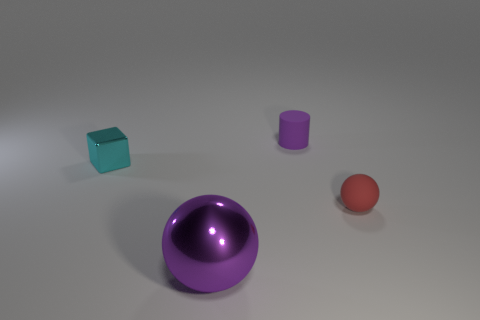Add 2 tiny matte things. How many objects exist? 6 Subtract all purple spheres. How many spheres are left? 1 Subtract 0 gray balls. How many objects are left? 4 Subtract all blocks. How many objects are left? 3 Subtract all cyan spheres. Subtract all red cylinders. How many spheres are left? 2 Subtract all blue cylinders. How many gray cubes are left? 0 Subtract all purple metal objects. Subtract all big metallic things. How many objects are left? 2 Add 3 tiny matte cylinders. How many tiny matte cylinders are left? 4 Add 4 tiny red balls. How many tiny red balls exist? 5 